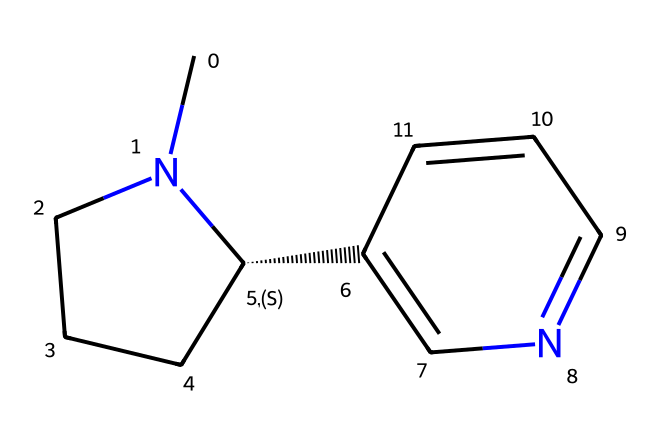What is the molecular formula of nicotine? To determine the molecular formula, count the number of each type of atom in the structure. The structure has 10 carbons (C), 14 hydrogens (H), and 2 nitrogens (N). Therefore, the molecular formula is C10H14N2.
Answer: C10H14N2 How many rings are present in the nicotine structure? By examining the structure, we can see there are two distinct cyclic parts, which constitute the two rings in the molecule.
Answer: 2 What type of compound is nicotine classified as? Nicotine is classified as an alkaloid, as it contains nitrogen and has effects on the nervous system, making it a biologically active compound.
Answer: alkaloid What is the significance of the nitrogen atoms in nicotine? The nitrogen atoms in nicotine contribute to its basic properties and are key to its interaction with nicotinic acetylcholine receptors, playing a crucial role in its addictive characteristics.
Answer: interactions How many double bonds are present in the nicotine structure? Reviewing the structure, there is one double bond present between carbon atoms, which can be observed in the structure provided.
Answer: 1 What kind of functional groups are found in nicotine? The nicotine structure primarily exhibits nitrogen-containing groups, specifically the presence of amine-type functionalities due to the nitrogen atoms in the ring.
Answer: amine 